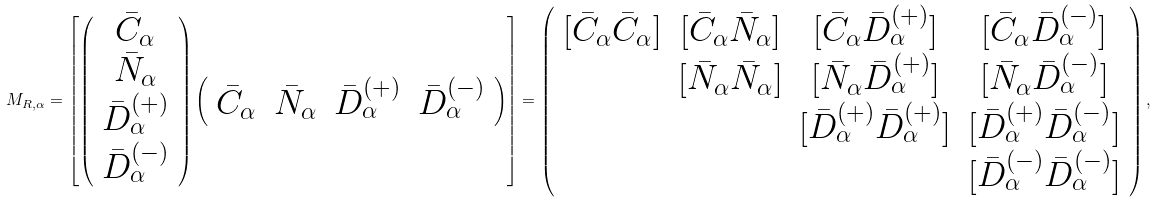Convert formula to latex. <formula><loc_0><loc_0><loc_500><loc_500>M _ { R , \alpha } = \left [ \left ( \begin{array} { c } { \bar { C } } _ { \alpha } \\ { \bar { N } } _ { \alpha } \\ { \bar { D } } ^ { ( + ) } _ { \alpha } \\ { \bar { D } } ^ { ( - ) } _ { \alpha } \end{array} \right ) \left ( \begin{array} { c c c c } { \bar { C } } _ { \alpha } & { \bar { N } } _ { \alpha } & { \bar { D } } ^ { ( + ) } _ { \alpha } & { \bar { D } } ^ { ( - ) } _ { \alpha } \end{array} \right ) \right ] = \left ( \begin{array} { c c c c } [ { \bar { C } } _ { \alpha } { \bar { C } } _ { \alpha } ] & [ { \bar { C } } _ { \alpha } { \bar { N } } _ { \alpha } ] & [ { \bar { C } } _ { \alpha } { \bar { D } } ^ { ( + ) } _ { \alpha } ] & [ { \bar { C } } _ { \alpha } { \bar { D } } ^ { ( - ) } _ { \alpha } ] \\ & [ { \bar { N } } _ { \alpha } { \bar { N } } _ { \alpha } ] & [ { \bar { N } } _ { \alpha } { \bar { D } } ^ { ( + ) } _ { \alpha } ] & [ { \bar { N } } _ { \alpha } { \bar { D } } ^ { ( - ) } _ { \alpha } ] \\ & & [ { \bar { D } } ^ { ( + ) } _ { \alpha } { \bar { D } } ^ { ( + ) } _ { \alpha } ] & [ { \bar { D } } ^ { ( + ) } _ { \alpha } { \bar { D } } ^ { ( - ) } _ { \alpha } ] \\ & & & [ { \bar { D } } ^ { ( - ) } _ { \alpha } { \bar { D } } ^ { ( - ) } _ { \alpha } ] \end{array} \right ) ,</formula> 